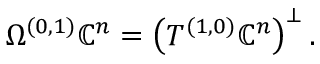<formula> <loc_0><loc_0><loc_500><loc_500>\Omega ^ { ( 0 , 1 ) } \mathbb { C } ^ { n } = \left ( T ^ { ( 1 , 0 ) } \mathbb { C } ^ { n } \right ) ^ { \bot } .</formula> 